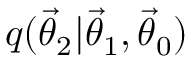Convert formula to latex. <formula><loc_0><loc_0><loc_500><loc_500>q ( { \vec { \theta } } _ { 2 } | { \vec { \theta } } _ { 1 } , { \vec { \theta } } _ { 0 } )</formula> 